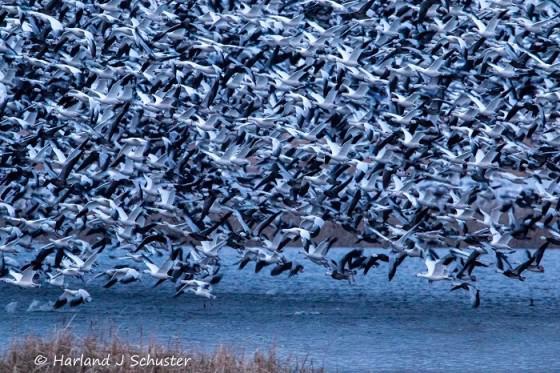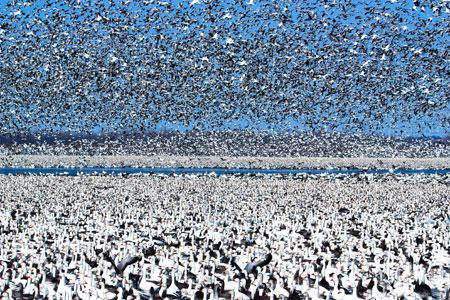The first image is the image on the left, the second image is the image on the right. Analyze the images presented: Is the assertion "In at least one of the images, you can see the ground at the bottom of the frame." valid? Answer yes or no. Yes. The first image is the image on the left, the second image is the image on the right. Assess this claim about the two images: "A horizon is visible behind a mass of flying birds in at least one image, and no image has any one bird that stands out as different from the rest.". Correct or not? Answer yes or no. Yes. 